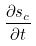Convert formula to latex. <formula><loc_0><loc_0><loc_500><loc_500>\frac { \partial s _ { c } } { \partial t }</formula> 